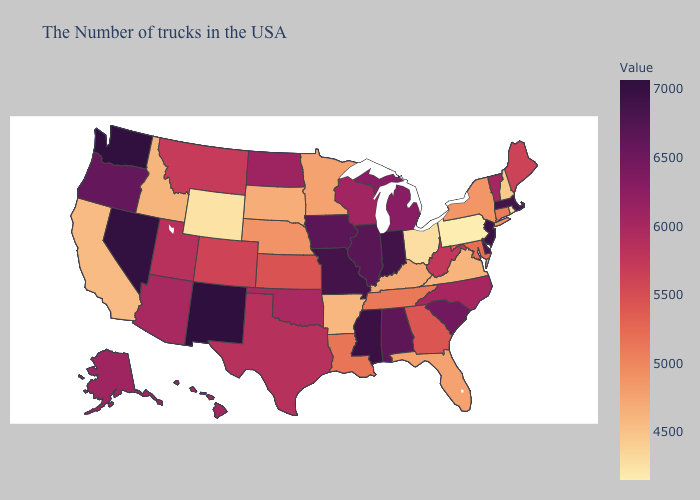Does Massachusetts have the highest value in the Northeast?
Be succinct. No. Does Hawaii have the highest value in the USA?
Give a very brief answer. No. Which states have the highest value in the USA?
Write a very short answer. New Mexico. 